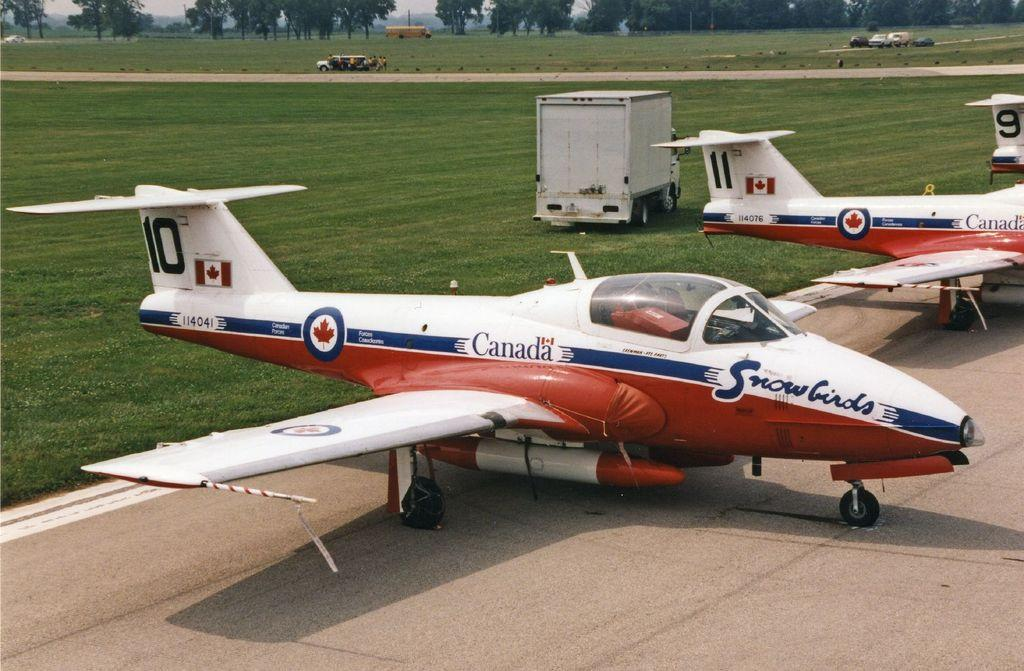<image>
Share a concise interpretation of the image provided. Several snowbirds from Canada sit on a small runway. 